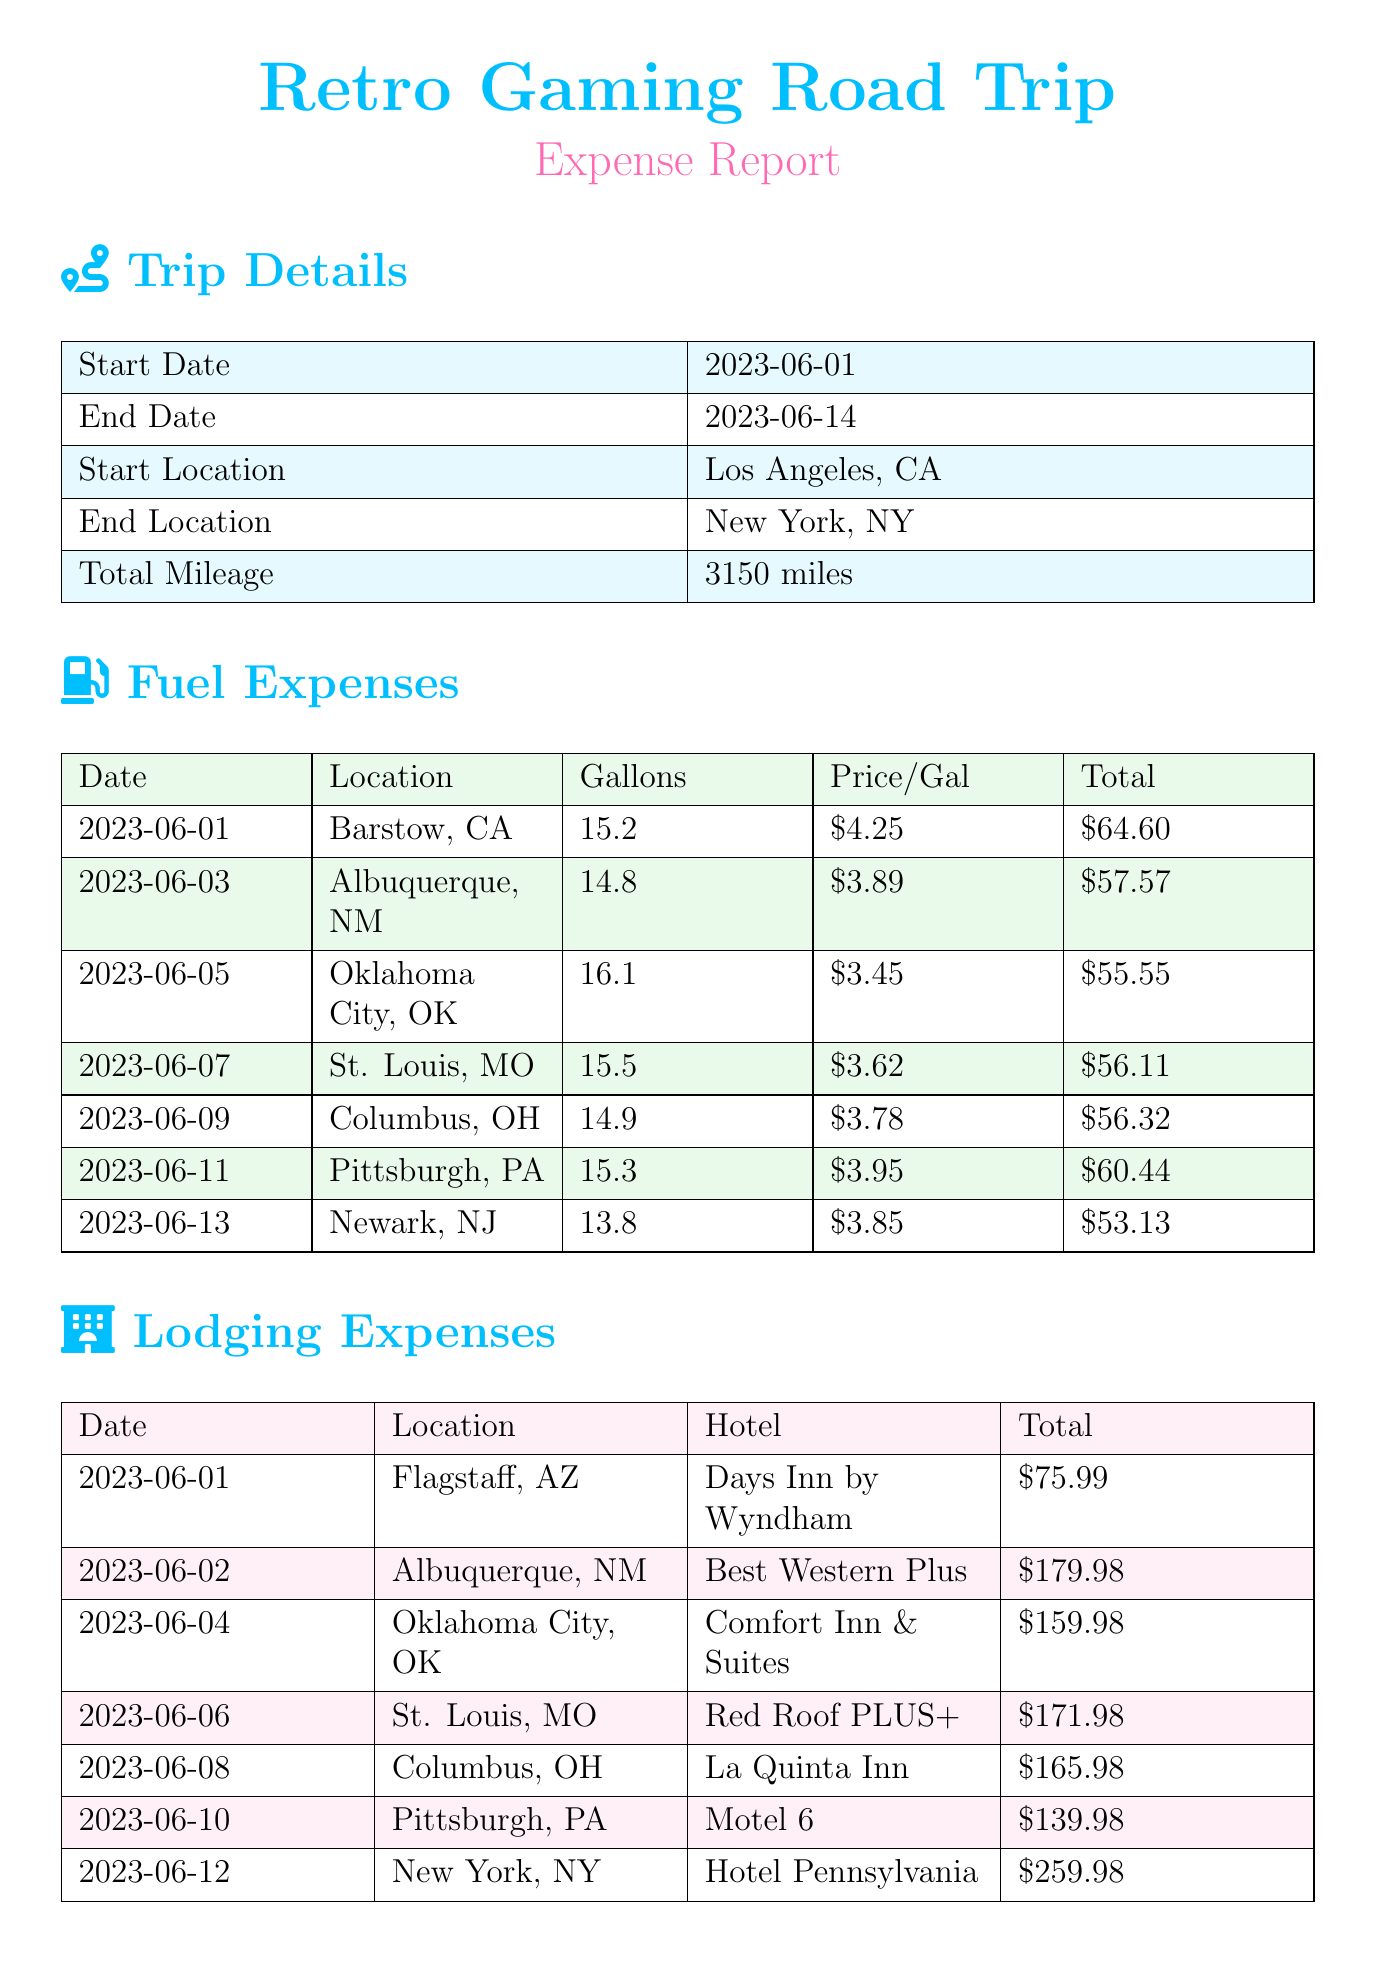what is the total mileage of the trip? The total mileage is listed under trip details, which shows 3150 miles.
Answer: 3150 miles who is the hotel provider in Flagstaff, AZ? The lodging expenses include a hotel stay in Flagstaff, AZ, with the provider being Days Inn by Wyndham.
Answer: Days Inn by Wyndham how much did the retro gaming acquisitions cost in New York, NY? The total cost of acquisitions in New York, NY is shown in the retro gaming acquisitions section, which is $249.97.
Answer: $249.97 what date did the trip start? The start date of the trip is stated in the trip details section, which is June 1, 2023.
Answer: June 1, 2023 which location had the highest lodging expense? The highest lodging expense is found in the lodging expenses section, which is for Hotel Pennsylvania in New York, NY, totaling $259.98.
Answer: Hotel Pennsylvania how much was spent on fuel in St. Louis, MO? The fuel expenses for St. Louis, MO is detailed under fuel expenses, totaling $56.11.
Answer: $56.11 what is the total amount spent on retro gaming items? The total amount spent on retro gaming items is calculated by summing all acquisition costs, which totals $664.87.
Answer: $664.87 which state did the trip start in? The start location of the trip is specified in the document as Los Angeles, CA, which is in California.
Answer: California how many nights were spent in Albuquerque, NM? The lodging expenses for Albuquerque, NM indicate a total of 2 nights at the Best Western Plus.
Answer: 2 nights 